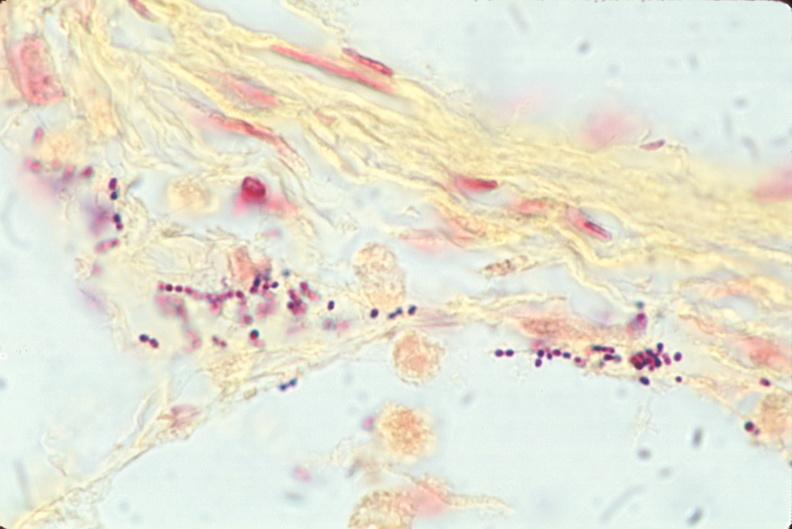do this image shows lung, bronchopneumonia, bacterial, tissue gram stain?
Answer the question using a single word or phrase. Yes 